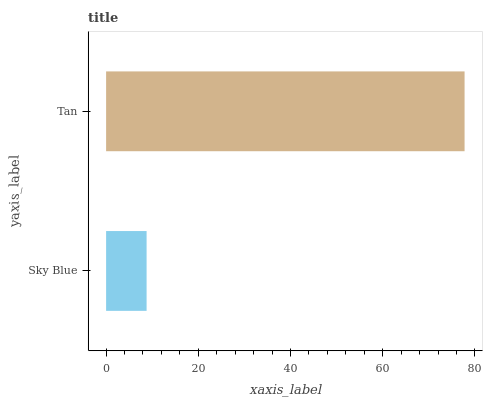Is Sky Blue the minimum?
Answer yes or no. Yes. Is Tan the maximum?
Answer yes or no. Yes. Is Tan the minimum?
Answer yes or no. No. Is Tan greater than Sky Blue?
Answer yes or no. Yes. Is Sky Blue less than Tan?
Answer yes or no. Yes. Is Sky Blue greater than Tan?
Answer yes or no. No. Is Tan less than Sky Blue?
Answer yes or no. No. Is Tan the high median?
Answer yes or no. Yes. Is Sky Blue the low median?
Answer yes or no. Yes. Is Sky Blue the high median?
Answer yes or no. No. Is Tan the low median?
Answer yes or no. No. 